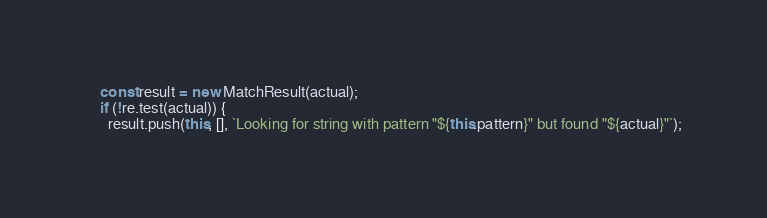Convert code to text. <code><loc_0><loc_0><loc_500><loc_500><_TypeScript_>    const result = new MatchResult(actual);
    if (!re.test(actual)) {
      result.push(this, [], `Looking for string with pattern "${this.pattern}" but found "${actual}"`);</code> 